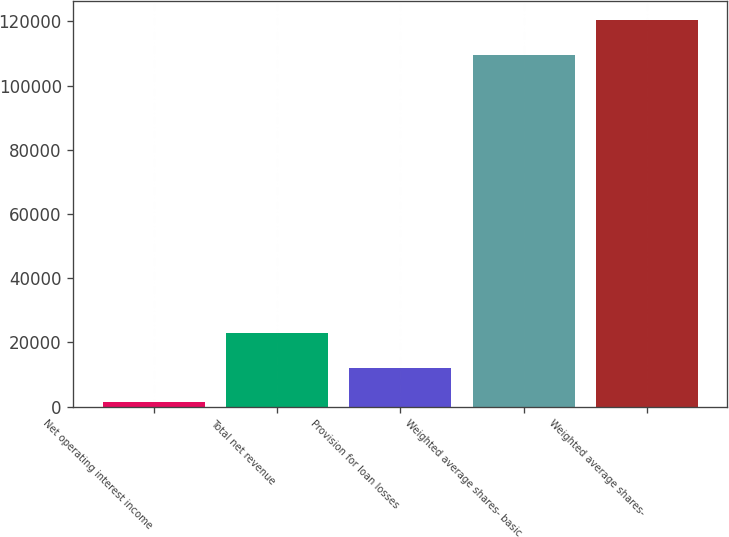Convert chart. <chart><loc_0><loc_0><loc_500><loc_500><bar_chart><fcel>Net operating interest income<fcel>Total net revenue<fcel>Provision for loan losses<fcel>Weighted average shares- basic<fcel>Weighted average shares-<nl><fcel>1260.6<fcel>22917.3<fcel>12088.9<fcel>109544<fcel>120372<nl></chart> 